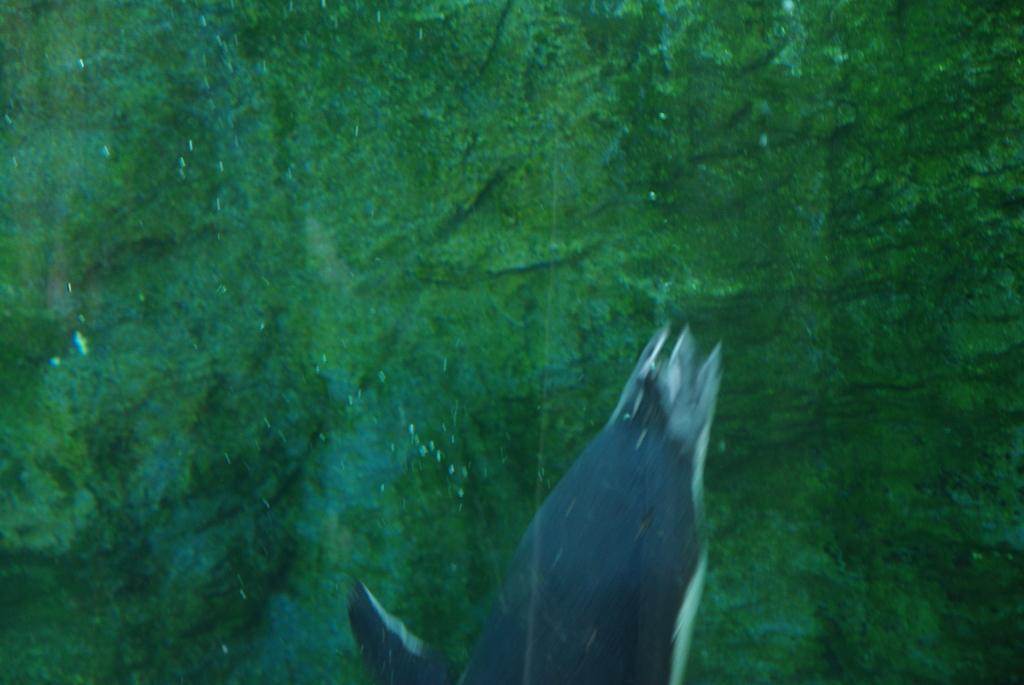Please provide a concise description of this image. In the image it seems to be a aquatic animal in the middle and below the floor is in green color. 